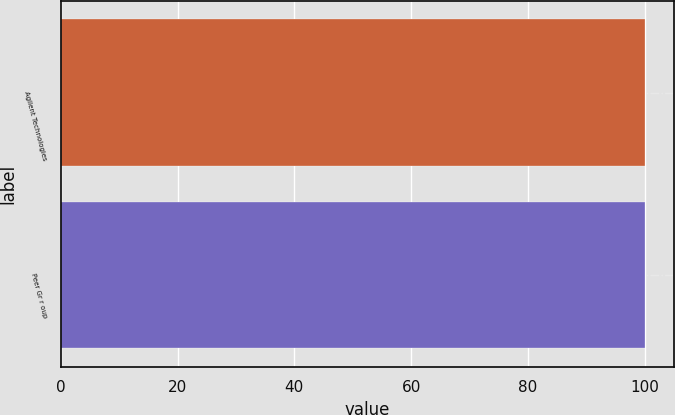<chart> <loc_0><loc_0><loc_500><loc_500><bar_chart><fcel>Agilent Technologies<fcel>Peer Gr r oup<nl><fcel>100<fcel>100.1<nl></chart> 